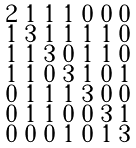<formula> <loc_0><loc_0><loc_500><loc_500>\begin{smallmatrix} 2 & 1 & 1 & 1 & 0 & 0 & 0 \\ 1 & 3 & 1 & 1 & 1 & 1 & 0 \\ 1 & 1 & 3 & 0 & 1 & 1 & 0 \\ 1 & 1 & 0 & 3 & 1 & 0 & 1 \\ 0 & 1 & 1 & 1 & 3 & 0 & 0 \\ 0 & 1 & 1 & 0 & 0 & 3 & 1 \\ 0 & 0 & 0 & 1 & 0 & 1 & 3 \end{smallmatrix}</formula> 